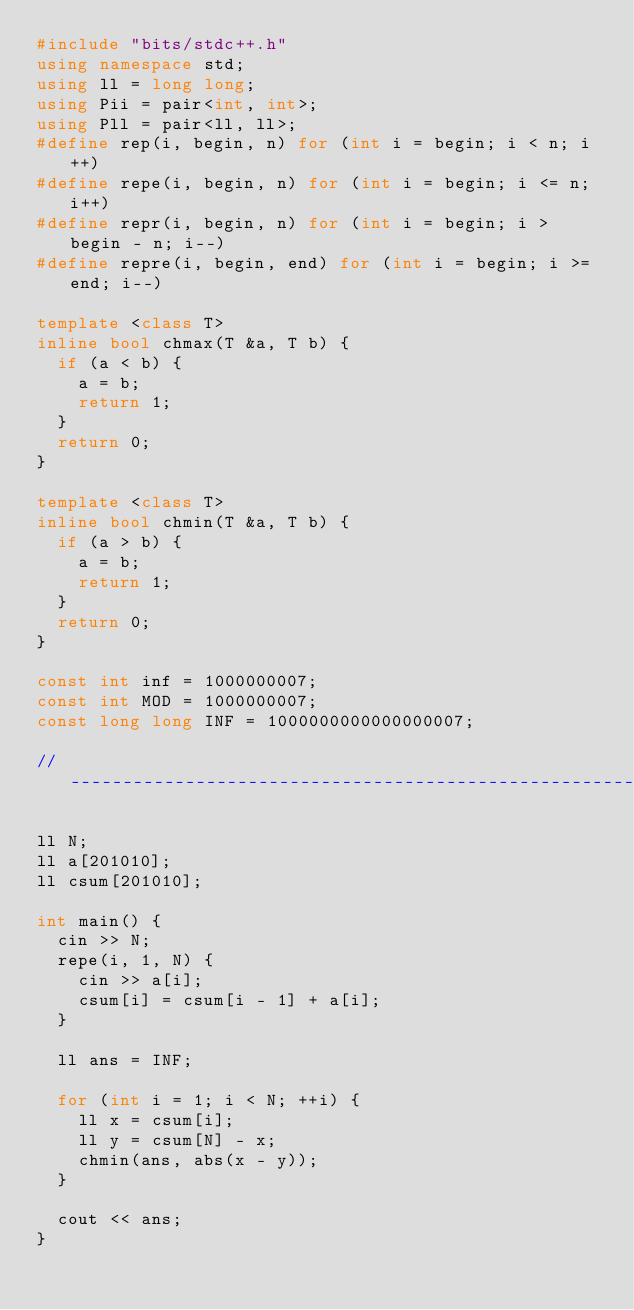Convert code to text. <code><loc_0><loc_0><loc_500><loc_500><_C++_>#include "bits/stdc++.h"
using namespace std;
using ll = long long;
using Pii = pair<int, int>;
using Pll = pair<ll, ll>;
#define rep(i, begin, n) for (int i = begin; i < n; i++)
#define repe(i, begin, n) for (int i = begin; i <= n; i++)
#define repr(i, begin, n) for (int i = begin; i > begin - n; i--)
#define repre(i, begin, end) for (int i = begin; i >= end; i--)

template <class T>
inline bool chmax(T &a, T b) {
  if (a < b) {
    a = b;
    return 1;
  }
  return 0;
}

template <class T>
inline bool chmin(T &a, T b) {
  if (a > b) {
    a = b;
    return 1;
  }
  return 0;
}

const int inf = 1000000007;
const int MOD = 1000000007;
const long long INF = 1000000000000000007;

// -------------------------------------------------------

ll N;
ll a[201010];
ll csum[201010];

int main() {
  cin >> N;
  repe(i, 1, N) {
    cin >> a[i];
    csum[i] = csum[i - 1] + a[i];
  }

  ll ans = INF;

  for (int i = 1; i < N; ++i) {
    ll x = csum[i];
    ll y = csum[N] - x;
    chmin(ans, abs(x - y));
  }

  cout << ans;
}
</code> 